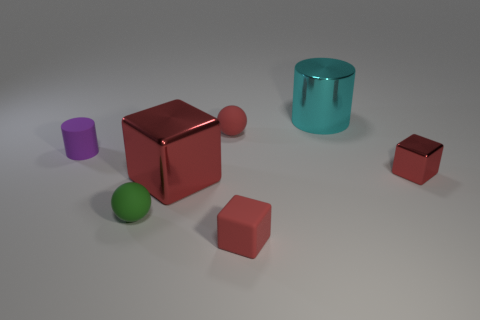There is a cyan metal object that is the same shape as the tiny purple thing; what size is it?
Offer a terse response. Large. Do the cube on the right side of the large cyan thing and the large thing behind the big shiny block have the same material?
Offer a terse response. Yes. The tiny metal object is what shape?
Your response must be concise. Cube. Are there the same number of small matte balls in front of the matte cube and tiny red balls?
Give a very brief answer. No. There is a ball that is the same color as the tiny metallic block; what size is it?
Offer a very short reply. Small. Are there any small cylinders made of the same material as the green ball?
Offer a terse response. Yes. Is the shape of the matte thing that is behind the purple cylinder the same as the small green rubber thing in front of the purple matte cylinder?
Give a very brief answer. Yes. Are any small cyan cubes visible?
Offer a terse response. No. What color is the rubber block that is the same size as the red rubber sphere?
Provide a short and direct response. Red. What number of small red metal objects are the same shape as the green thing?
Your answer should be very brief. 0. 